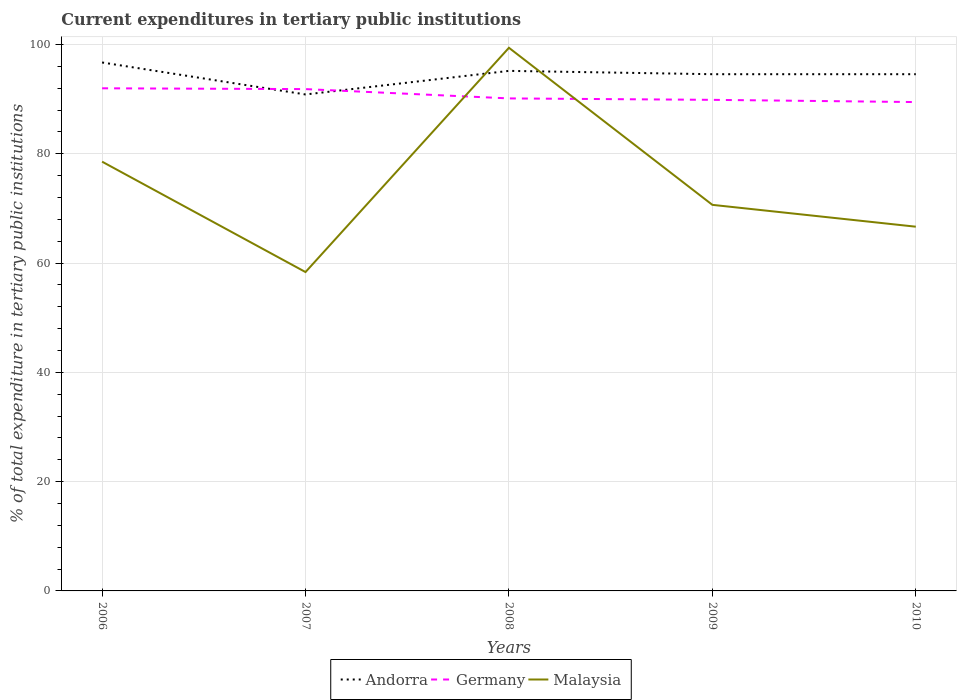Is the number of lines equal to the number of legend labels?
Keep it short and to the point. Yes. Across all years, what is the maximum current expenditures in tertiary public institutions in Andorra?
Make the answer very short. 90.84. In which year was the current expenditures in tertiary public institutions in Andorra maximum?
Provide a succinct answer. 2007. What is the total current expenditures in tertiary public institutions in Malaysia in the graph?
Offer a very short reply. -8.3. What is the difference between the highest and the second highest current expenditures in tertiary public institutions in Andorra?
Give a very brief answer. 5.85. What is the difference between the highest and the lowest current expenditures in tertiary public institutions in Germany?
Offer a very short reply. 2. How many lines are there?
Your answer should be compact. 3. How many years are there in the graph?
Your answer should be compact. 5. What is the difference between two consecutive major ticks on the Y-axis?
Give a very brief answer. 20. Are the values on the major ticks of Y-axis written in scientific E-notation?
Your answer should be compact. No. Does the graph contain grids?
Provide a short and direct response. Yes. Where does the legend appear in the graph?
Make the answer very short. Bottom center. How many legend labels are there?
Offer a terse response. 3. How are the legend labels stacked?
Provide a short and direct response. Horizontal. What is the title of the graph?
Your answer should be very brief. Current expenditures in tertiary public institutions. What is the label or title of the Y-axis?
Provide a succinct answer. % of total expenditure in tertiary public institutions. What is the % of total expenditure in tertiary public institutions of Andorra in 2006?
Your answer should be compact. 96.7. What is the % of total expenditure in tertiary public institutions in Germany in 2006?
Offer a terse response. 91.97. What is the % of total expenditure in tertiary public institutions in Malaysia in 2006?
Ensure brevity in your answer.  78.55. What is the % of total expenditure in tertiary public institutions in Andorra in 2007?
Provide a short and direct response. 90.84. What is the % of total expenditure in tertiary public institutions of Germany in 2007?
Make the answer very short. 91.83. What is the % of total expenditure in tertiary public institutions of Malaysia in 2007?
Make the answer very short. 58.35. What is the % of total expenditure in tertiary public institutions of Andorra in 2008?
Ensure brevity in your answer.  95.16. What is the % of total expenditure in tertiary public institutions in Germany in 2008?
Provide a short and direct response. 90.12. What is the % of total expenditure in tertiary public institutions of Malaysia in 2008?
Ensure brevity in your answer.  99.38. What is the % of total expenditure in tertiary public institutions of Andorra in 2009?
Keep it short and to the point. 94.55. What is the % of total expenditure in tertiary public institutions in Germany in 2009?
Provide a succinct answer. 89.86. What is the % of total expenditure in tertiary public institutions of Malaysia in 2009?
Ensure brevity in your answer.  70.64. What is the % of total expenditure in tertiary public institutions of Andorra in 2010?
Offer a very short reply. 94.55. What is the % of total expenditure in tertiary public institutions of Germany in 2010?
Provide a succinct answer. 89.45. What is the % of total expenditure in tertiary public institutions in Malaysia in 2010?
Give a very brief answer. 66.65. Across all years, what is the maximum % of total expenditure in tertiary public institutions in Andorra?
Ensure brevity in your answer.  96.7. Across all years, what is the maximum % of total expenditure in tertiary public institutions of Germany?
Give a very brief answer. 91.97. Across all years, what is the maximum % of total expenditure in tertiary public institutions in Malaysia?
Keep it short and to the point. 99.38. Across all years, what is the minimum % of total expenditure in tertiary public institutions in Andorra?
Your answer should be compact. 90.84. Across all years, what is the minimum % of total expenditure in tertiary public institutions of Germany?
Provide a short and direct response. 89.45. Across all years, what is the minimum % of total expenditure in tertiary public institutions of Malaysia?
Provide a short and direct response. 58.35. What is the total % of total expenditure in tertiary public institutions of Andorra in the graph?
Keep it short and to the point. 471.8. What is the total % of total expenditure in tertiary public institutions in Germany in the graph?
Offer a very short reply. 453.23. What is the total % of total expenditure in tertiary public institutions in Malaysia in the graph?
Your response must be concise. 373.57. What is the difference between the % of total expenditure in tertiary public institutions of Andorra in 2006 and that in 2007?
Offer a very short reply. 5.85. What is the difference between the % of total expenditure in tertiary public institutions of Germany in 2006 and that in 2007?
Provide a short and direct response. 0.15. What is the difference between the % of total expenditure in tertiary public institutions of Malaysia in 2006 and that in 2007?
Make the answer very short. 20.2. What is the difference between the % of total expenditure in tertiary public institutions in Andorra in 2006 and that in 2008?
Provide a short and direct response. 1.54. What is the difference between the % of total expenditure in tertiary public institutions of Germany in 2006 and that in 2008?
Provide a succinct answer. 1.85. What is the difference between the % of total expenditure in tertiary public institutions of Malaysia in 2006 and that in 2008?
Make the answer very short. -20.84. What is the difference between the % of total expenditure in tertiary public institutions of Andorra in 2006 and that in 2009?
Give a very brief answer. 2.15. What is the difference between the % of total expenditure in tertiary public institutions in Germany in 2006 and that in 2009?
Keep it short and to the point. 2.11. What is the difference between the % of total expenditure in tertiary public institutions of Malaysia in 2006 and that in 2009?
Keep it short and to the point. 7.9. What is the difference between the % of total expenditure in tertiary public institutions of Andorra in 2006 and that in 2010?
Make the answer very short. 2.15. What is the difference between the % of total expenditure in tertiary public institutions of Germany in 2006 and that in 2010?
Your response must be concise. 2.52. What is the difference between the % of total expenditure in tertiary public institutions of Malaysia in 2006 and that in 2010?
Keep it short and to the point. 11.9. What is the difference between the % of total expenditure in tertiary public institutions in Andorra in 2007 and that in 2008?
Your answer should be compact. -4.32. What is the difference between the % of total expenditure in tertiary public institutions of Germany in 2007 and that in 2008?
Provide a succinct answer. 1.7. What is the difference between the % of total expenditure in tertiary public institutions of Malaysia in 2007 and that in 2008?
Your answer should be compact. -41.04. What is the difference between the % of total expenditure in tertiary public institutions in Andorra in 2007 and that in 2009?
Make the answer very short. -3.71. What is the difference between the % of total expenditure in tertiary public institutions in Germany in 2007 and that in 2009?
Provide a succinct answer. 1.97. What is the difference between the % of total expenditure in tertiary public institutions in Malaysia in 2007 and that in 2009?
Offer a terse response. -12.3. What is the difference between the % of total expenditure in tertiary public institutions of Andorra in 2007 and that in 2010?
Provide a succinct answer. -3.71. What is the difference between the % of total expenditure in tertiary public institutions in Germany in 2007 and that in 2010?
Your answer should be very brief. 2.37. What is the difference between the % of total expenditure in tertiary public institutions of Malaysia in 2007 and that in 2010?
Ensure brevity in your answer.  -8.3. What is the difference between the % of total expenditure in tertiary public institutions of Andorra in 2008 and that in 2009?
Your response must be concise. 0.61. What is the difference between the % of total expenditure in tertiary public institutions in Germany in 2008 and that in 2009?
Your response must be concise. 0.26. What is the difference between the % of total expenditure in tertiary public institutions in Malaysia in 2008 and that in 2009?
Your response must be concise. 28.74. What is the difference between the % of total expenditure in tertiary public institutions of Andorra in 2008 and that in 2010?
Make the answer very short. 0.61. What is the difference between the % of total expenditure in tertiary public institutions in Germany in 2008 and that in 2010?
Give a very brief answer. 0.67. What is the difference between the % of total expenditure in tertiary public institutions in Malaysia in 2008 and that in 2010?
Your answer should be very brief. 32.74. What is the difference between the % of total expenditure in tertiary public institutions of Andorra in 2009 and that in 2010?
Your answer should be very brief. 0. What is the difference between the % of total expenditure in tertiary public institutions of Germany in 2009 and that in 2010?
Give a very brief answer. 0.41. What is the difference between the % of total expenditure in tertiary public institutions of Malaysia in 2009 and that in 2010?
Offer a terse response. 4. What is the difference between the % of total expenditure in tertiary public institutions of Andorra in 2006 and the % of total expenditure in tertiary public institutions of Germany in 2007?
Your answer should be compact. 4.87. What is the difference between the % of total expenditure in tertiary public institutions in Andorra in 2006 and the % of total expenditure in tertiary public institutions in Malaysia in 2007?
Your response must be concise. 38.35. What is the difference between the % of total expenditure in tertiary public institutions in Germany in 2006 and the % of total expenditure in tertiary public institutions in Malaysia in 2007?
Your answer should be compact. 33.62. What is the difference between the % of total expenditure in tertiary public institutions of Andorra in 2006 and the % of total expenditure in tertiary public institutions of Germany in 2008?
Keep it short and to the point. 6.57. What is the difference between the % of total expenditure in tertiary public institutions of Andorra in 2006 and the % of total expenditure in tertiary public institutions of Malaysia in 2008?
Your response must be concise. -2.69. What is the difference between the % of total expenditure in tertiary public institutions in Germany in 2006 and the % of total expenditure in tertiary public institutions in Malaysia in 2008?
Your response must be concise. -7.41. What is the difference between the % of total expenditure in tertiary public institutions of Andorra in 2006 and the % of total expenditure in tertiary public institutions of Germany in 2009?
Offer a terse response. 6.84. What is the difference between the % of total expenditure in tertiary public institutions of Andorra in 2006 and the % of total expenditure in tertiary public institutions of Malaysia in 2009?
Offer a very short reply. 26.05. What is the difference between the % of total expenditure in tertiary public institutions in Germany in 2006 and the % of total expenditure in tertiary public institutions in Malaysia in 2009?
Your answer should be compact. 21.33. What is the difference between the % of total expenditure in tertiary public institutions of Andorra in 2006 and the % of total expenditure in tertiary public institutions of Germany in 2010?
Give a very brief answer. 7.24. What is the difference between the % of total expenditure in tertiary public institutions in Andorra in 2006 and the % of total expenditure in tertiary public institutions in Malaysia in 2010?
Offer a very short reply. 30.05. What is the difference between the % of total expenditure in tertiary public institutions in Germany in 2006 and the % of total expenditure in tertiary public institutions in Malaysia in 2010?
Offer a very short reply. 25.33. What is the difference between the % of total expenditure in tertiary public institutions in Andorra in 2007 and the % of total expenditure in tertiary public institutions in Germany in 2008?
Give a very brief answer. 0.72. What is the difference between the % of total expenditure in tertiary public institutions of Andorra in 2007 and the % of total expenditure in tertiary public institutions of Malaysia in 2008?
Offer a terse response. -8.54. What is the difference between the % of total expenditure in tertiary public institutions of Germany in 2007 and the % of total expenditure in tertiary public institutions of Malaysia in 2008?
Keep it short and to the point. -7.56. What is the difference between the % of total expenditure in tertiary public institutions of Andorra in 2007 and the % of total expenditure in tertiary public institutions of Malaysia in 2009?
Provide a succinct answer. 20.2. What is the difference between the % of total expenditure in tertiary public institutions in Germany in 2007 and the % of total expenditure in tertiary public institutions in Malaysia in 2009?
Give a very brief answer. 21.18. What is the difference between the % of total expenditure in tertiary public institutions in Andorra in 2007 and the % of total expenditure in tertiary public institutions in Germany in 2010?
Your response must be concise. 1.39. What is the difference between the % of total expenditure in tertiary public institutions in Andorra in 2007 and the % of total expenditure in tertiary public institutions in Malaysia in 2010?
Give a very brief answer. 24.2. What is the difference between the % of total expenditure in tertiary public institutions in Germany in 2007 and the % of total expenditure in tertiary public institutions in Malaysia in 2010?
Provide a short and direct response. 25.18. What is the difference between the % of total expenditure in tertiary public institutions of Andorra in 2008 and the % of total expenditure in tertiary public institutions of Germany in 2009?
Offer a terse response. 5.3. What is the difference between the % of total expenditure in tertiary public institutions of Andorra in 2008 and the % of total expenditure in tertiary public institutions of Malaysia in 2009?
Provide a succinct answer. 24.52. What is the difference between the % of total expenditure in tertiary public institutions of Germany in 2008 and the % of total expenditure in tertiary public institutions of Malaysia in 2009?
Provide a short and direct response. 19.48. What is the difference between the % of total expenditure in tertiary public institutions of Andorra in 2008 and the % of total expenditure in tertiary public institutions of Germany in 2010?
Provide a short and direct response. 5.71. What is the difference between the % of total expenditure in tertiary public institutions in Andorra in 2008 and the % of total expenditure in tertiary public institutions in Malaysia in 2010?
Keep it short and to the point. 28.51. What is the difference between the % of total expenditure in tertiary public institutions in Germany in 2008 and the % of total expenditure in tertiary public institutions in Malaysia in 2010?
Offer a terse response. 23.48. What is the difference between the % of total expenditure in tertiary public institutions in Andorra in 2009 and the % of total expenditure in tertiary public institutions in Germany in 2010?
Provide a succinct answer. 5.1. What is the difference between the % of total expenditure in tertiary public institutions in Andorra in 2009 and the % of total expenditure in tertiary public institutions in Malaysia in 2010?
Ensure brevity in your answer.  27.9. What is the difference between the % of total expenditure in tertiary public institutions in Germany in 2009 and the % of total expenditure in tertiary public institutions in Malaysia in 2010?
Keep it short and to the point. 23.21. What is the average % of total expenditure in tertiary public institutions of Andorra per year?
Provide a short and direct response. 94.36. What is the average % of total expenditure in tertiary public institutions in Germany per year?
Your response must be concise. 90.65. What is the average % of total expenditure in tertiary public institutions in Malaysia per year?
Give a very brief answer. 74.71. In the year 2006, what is the difference between the % of total expenditure in tertiary public institutions in Andorra and % of total expenditure in tertiary public institutions in Germany?
Provide a short and direct response. 4.72. In the year 2006, what is the difference between the % of total expenditure in tertiary public institutions in Andorra and % of total expenditure in tertiary public institutions in Malaysia?
Your response must be concise. 18.15. In the year 2006, what is the difference between the % of total expenditure in tertiary public institutions of Germany and % of total expenditure in tertiary public institutions of Malaysia?
Your answer should be very brief. 13.42. In the year 2007, what is the difference between the % of total expenditure in tertiary public institutions in Andorra and % of total expenditure in tertiary public institutions in Germany?
Offer a very short reply. -0.98. In the year 2007, what is the difference between the % of total expenditure in tertiary public institutions in Andorra and % of total expenditure in tertiary public institutions in Malaysia?
Your response must be concise. 32.5. In the year 2007, what is the difference between the % of total expenditure in tertiary public institutions in Germany and % of total expenditure in tertiary public institutions in Malaysia?
Your answer should be compact. 33.48. In the year 2008, what is the difference between the % of total expenditure in tertiary public institutions of Andorra and % of total expenditure in tertiary public institutions of Germany?
Make the answer very short. 5.04. In the year 2008, what is the difference between the % of total expenditure in tertiary public institutions in Andorra and % of total expenditure in tertiary public institutions in Malaysia?
Offer a very short reply. -4.22. In the year 2008, what is the difference between the % of total expenditure in tertiary public institutions of Germany and % of total expenditure in tertiary public institutions of Malaysia?
Your response must be concise. -9.26. In the year 2009, what is the difference between the % of total expenditure in tertiary public institutions of Andorra and % of total expenditure in tertiary public institutions of Germany?
Give a very brief answer. 4.69. In the year 2009, what is the difference between the % of total expenditure in tertiary public institutions in Andorra and % of total expenditure in tertiary public institutions in Malaysia?
Offer a terse response. 23.91. In the year 2009, what is the difference between the % of total expenditure in tertiary public institutions of Germany and % of total expenditure in tertiary public institutions of Malaysia?
Offer a very short reply. 19.21. In the year 2010, what is the difference between the % of total expenditure in tertiary public institutions in Andorra and % of total expenditure in tertiary public institutions in Germany?
Your answer should be very brief. 5.1. In the year 2010, what is the difference between the % of total expenditure in tertiary public institutions of Andorra and % of total expenditure in tertiary public institutions of Malaysia?
Offer a very short reply. 27.9. In the year 2010, what is the difference between the % of total expenditure in tertiary public institutions of Germany and % of total expenditure in tertiary public institutions of Malaysia?
Your answer should be very brief. 22.81. What is the ratio of the % of total expenditure in tertiary public institutions of Andorra in 2006 to that in 2007?
Your answer should be very brief. 1.06. What is the ratio of the % of total expenditure in tertiary public institutions of Malaysia in 2006 to that in 2007?
Provide a short and direct response. 1.35. What is the ratio of the % of total expenditure in tertiary public institutions of Andorra in 2006 to that in 2008?
Provide a succinct answer. 1.02. What is the ratio of the % of total expenditure in tertiary public institutions in Germany in 2006 to that in 2008?
Your response must be concise. 1.02. What is the ratio of the % of total expenditure in tertiary public institutions of Malaysia in 2006 to that in 2008?
Provide a succinct answer. 0.79. What is the ratio of the % of total expenditure in tertiary public institutions of Andorra in 2006 to that in 2009?
Your answer should be very brief. 1.02. What is the ratio of the % of total expenditure in tertiary public institutions of Germany in 2006 to that in 2009?
Keep it short and to the point. 1.02. What is the ratio of the % of total expenditure in tertiary public institutions of Malaysia in 2006 to that in 2009?
Ensure brevity in your answer.  1.11. What is the ratio of the % of total expenditure in tertiary public institutions of Andorra in 2006 to that in 2010?
Offer a very short reply. 1.02. What is the ratio of the % of total expenditure in tertiary public institutions of Germany in 2006 to that in 2010?
Offer a very short reply. 1.03. What is the ratio of the % of total expenditure in tertiary public institutions in Malaysia in 2006 to that in 2010?
Provide a succinct answer. 1.18. What is the ratio of the % of total expenditure in tertiary public institutions of Andorra in 2007 to that in 2008?
Keep it short and to the point. 0.95. What is the ratio of the % of total expenditure in tertiary public institutions in Germany in 2007 to that in 2008?
Provide a short and direct response. 1.02. What is the ratio of the % of total expenditure in tertiary public institutions of Malaysia in 2007 to that in 2008?
Keep it short and to the point. 0.59. What is the ratio of the % of total expenditure in tertiary public institutions of Andorra in 2007 to that in 2009?
Make the answer very short. 0.96. What is the ratio of the % of total expenditure in tertiary public institutions in Germany in 2007 to that in 2009?
Ensure brevity in your answer.  1.02. What is the ratio of the % of total expenditure in tertiary public institutions in Malaysia in 2007 to that in 2009?
Provide a short and direct response. 0.83. What is the ratio of the % of total expenditure in tertiary public institutions in Andorra in 2007 to that in 2010?
Give a very brief answer. 0.96. What is the ratio of the % of total expenditure in tertiary public institutions in Germany in 2007 to that in 2010?
Offer a terse response. 1.03. What is the ratio of the % of total expenditure in tertiary public institutions of Malaysia in 2007 to that in 2010?
Make the answer very short. 0.88. What is the ratio of the % of total expenditure in tertiary public institutions of Andorra in 2008 to that in 2009?
Offer a terse response. 1.01. What is the ratio of the % of total expenditure in tertiary public institutions in Germany in 2008 to that in 2009?
Your response must be concise. 1. What is the ratio of the % of total expenditure in tertiary public institutions of Malaysia in 2008 to that in 2009?
Your answer should be compact. 1.41. What is the ratio of the % of total expenditure in tertiary public institutions in Andorra in 2008 to that in 2010?
Make the answer very short. 1.01. What is the ratio of the % of total expenditure in tertiary public institutions of Germany in 2008 to that in 2010?
Provide a short and direct response. 1.01. What is the ratio of the % of total expenditure in tertiary public institutions of Malaysia in 2008 to that in 2010?
Provide a short and direct response. 1.49. What is the ratio of the % of total expenditure in tertiary public institutions in Andorra in 2009 to that in 2010?
Make the answer very short. 1. What is the ratio of the % of total expenditure in tertiary public institutions in Malaysia in 2009 to that in 2010?
Provide a short and direct response. 1.06. What is the difference between the highest and the second highest % of total expenditure in tertiary public institutions in Andorra?
Provide a short and direct response. 1.54. What is the difference between the highest and the second highest % of total expenditure in tertiary public institutions of Germany?
Make the answer very short. 0.15. What is the difference between the highest and the second highest % of total expenditure in tertiary public institutions of Malaysia?
Keep it short and to the point. 20.84. What is the difference between the highest and the lowest % of total expenditure in tertiary public institutions of Andorra?
Keep it short and to the point. 5.85. What is the difference between the highest and the lowest % of total expenditure in tertiary public institutions of Germany?
Ensure brevity in your answer.  2.52. What is the difference between the highest and the lowest % of total expenditure in tertiary public institutions in Malaysia?
Provide a short and direct response. 41.04. 